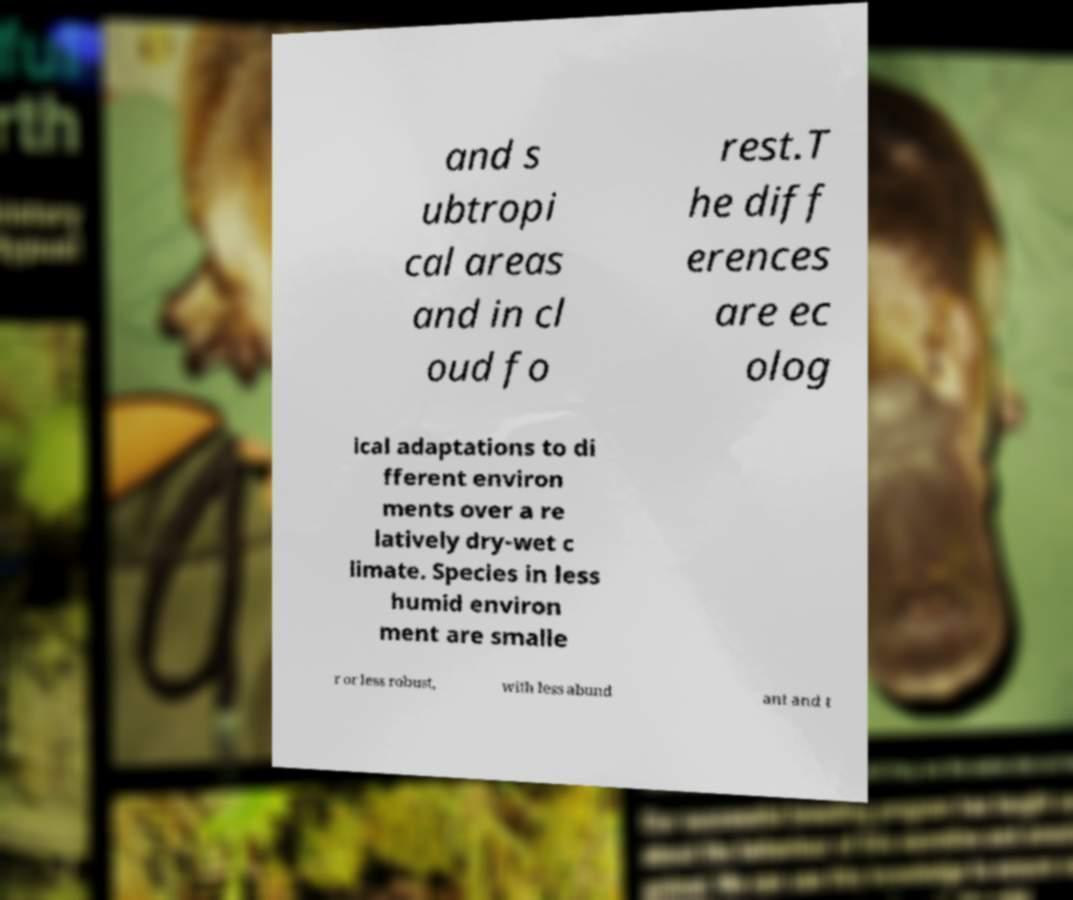What messages or text are displayed in this image? I need them in a readable, typed format. and s ubtropi cal areas and in cl oud fo rest.T he diff erences are ec olog ical adaptations to di fferent environ ments over a re latively dry-wet c limate. Species in less humid environ ment are smalle r or less robust, with less abund ant and t 